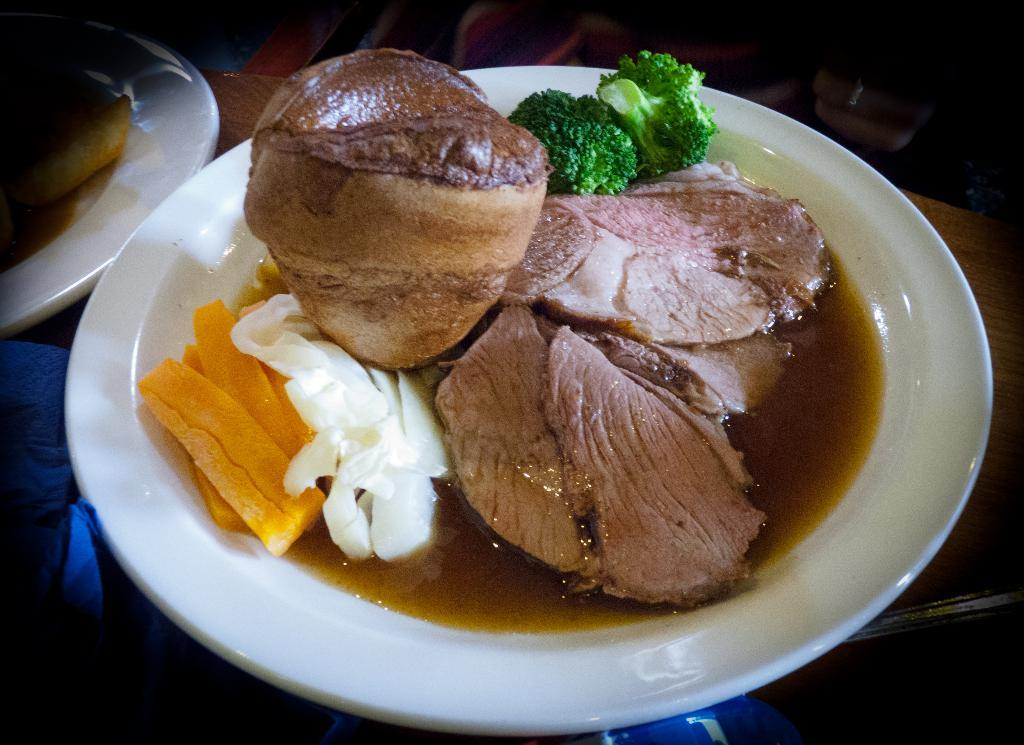What is on the plates that are visible in the image? There are plates with food in the image. What else can be seen on the table besides the plates? There are objects on the table. How would you describe the lighting in the image? The background of the image is dark. What type of dog can be seen playing with a hobby in the image? There is no dog or hobby present in the image. 